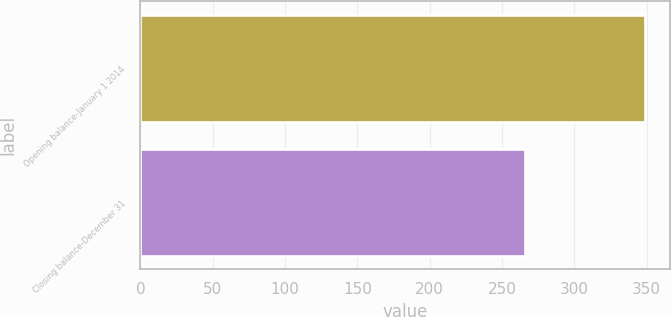Convert chart to OTSL. <chart><loc_0><loc_0><loc_500><loc_500><bar_chart><fcel>Opening balance-January 1 2014<fcel>Closing balance-December 31<nl><fcel>349<fcel>266<nl></chart> 